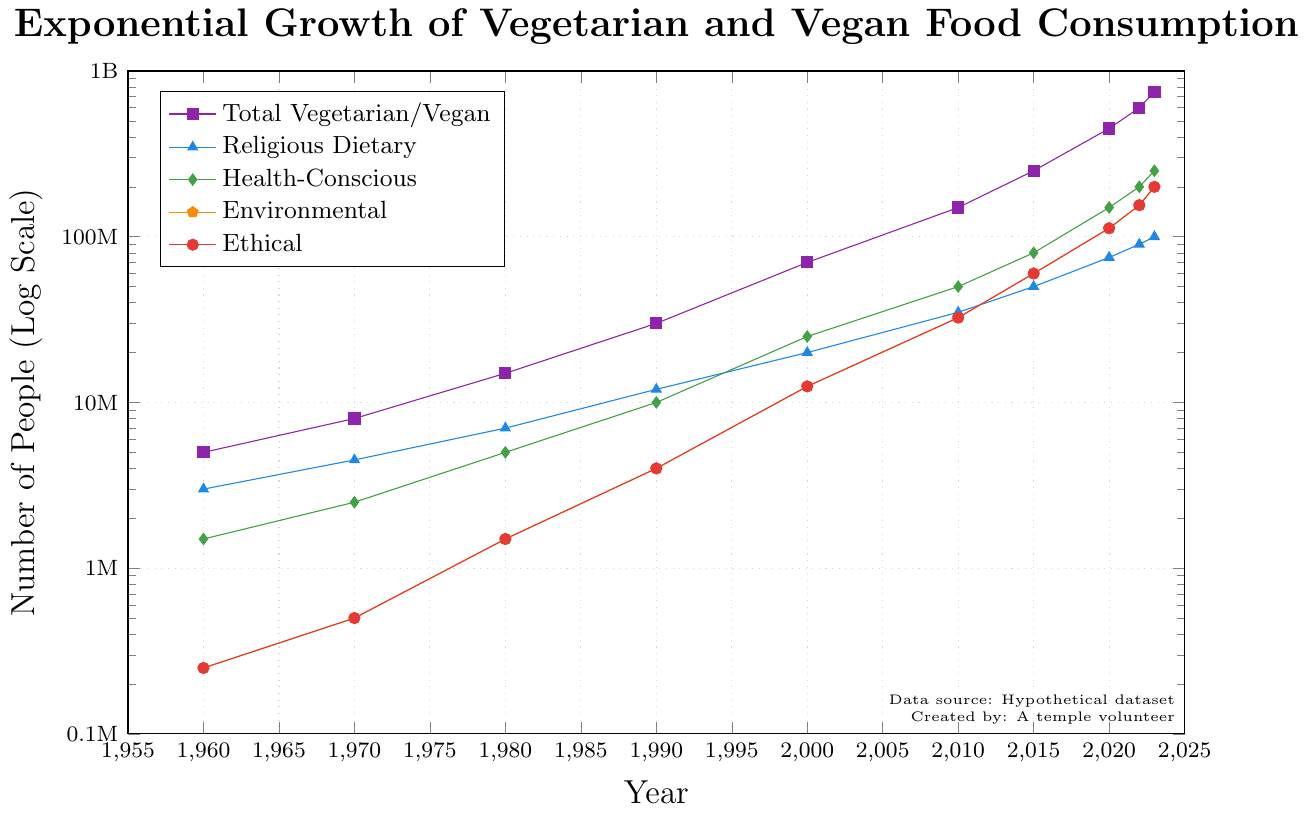How many more people adopted a vegetarian/vegan lifestyle for health-conscious reasons than for ethical reasons in 2023? According to the chart, in 2023, 250 million people adopted a vegetarian/vegan lifestyle for health-conscious reasons, while 200 million did so for ethical reasons. The difference is 250 million - 200 million = 50 million.
Answer: 50 million What is the main reason behind vegetarian/vegan adoption in 2020? By visually inspecting the length of the lines at the 2020 point on the x-axis, the highest data point is for health-conscious reasons, which is 150 million.
Answer: Health-conscious reasons Compare the growth in total vegetarian/vegan food consumption between 2000 and 2010 and between 2010 and 2020. Which period had a higher growth? From 2000 to 2010, the total consumption increases from 70 million to 150 million: 150M - 70M = 80M. From 2010 to 2020, it increases from 150 million to 450 million: 450M - 150M = 300M. Therefore, the period from 2010 to 2020 had a higher growth.
Answer: 2010 to 2020 How does the trend for vegetarian/vegan adoption for religious dietary reasons compare visually to that for environmental reasons? The lines for religious dietary reasons and environmental reasons are both increasing, but the one for environmental reasons starts lower and catches up over time. By 2023, both lines approach similar values, but the environmental reasons graph shows a steeper increase.
Answer: Steeper increase for environmental reasons What was the total number of people adopting a vegetarian/vegan diet for environmental reasons in 1980 and 1990 combined? From the chart, in 1980 the number was 1.5 million and in 1990 it was 4 million. The sum is 1.5M + 4M = 5.5M.
Answer: 5.5 million Which reason showed the most exponential growth from 1960 to 2023? By comparing the slopes of the lines from 1960 to 2023, the line for health-conscious reasons shows the steepest and most dramatic increase from 1.5 million in 1960 to 250 million in 2023.
Answer: Health-conscious reasons Looking at the year 2022, did the number of people adopting for environmental reasons exceed those adopting for religious dietary reasons? In 2022, the number for environmental reasons is 155 million and for religious reasons is 90 million. Since 155 million is more than 90 million, the environmental reasons surpassed the religious dietary reasons.
Answer: Yes In which year did the total number of vegetarians/vegans first exceed 100 million? According to the chart, the total number exceeds 100 million in the year 2000, when the count reaches 150 million.
Answer: 2000 By what factor did the total number of vegetarians/vegans increase from 1960 to 2023? In 1960, the total was 5 million, and in 2023 it is 750 million. The factor of increase is 750 million / 5 million = 150.
Answer: 150 What percentage of the total vegetarian/vegan population in 2023 was for ethical reasons? In 2023, the total population is 750 million, and 200 million of these are for ethical reasons. The percentage is (200 million / 750 million) * 100 = 26.67%.
Answer: 26.67% 